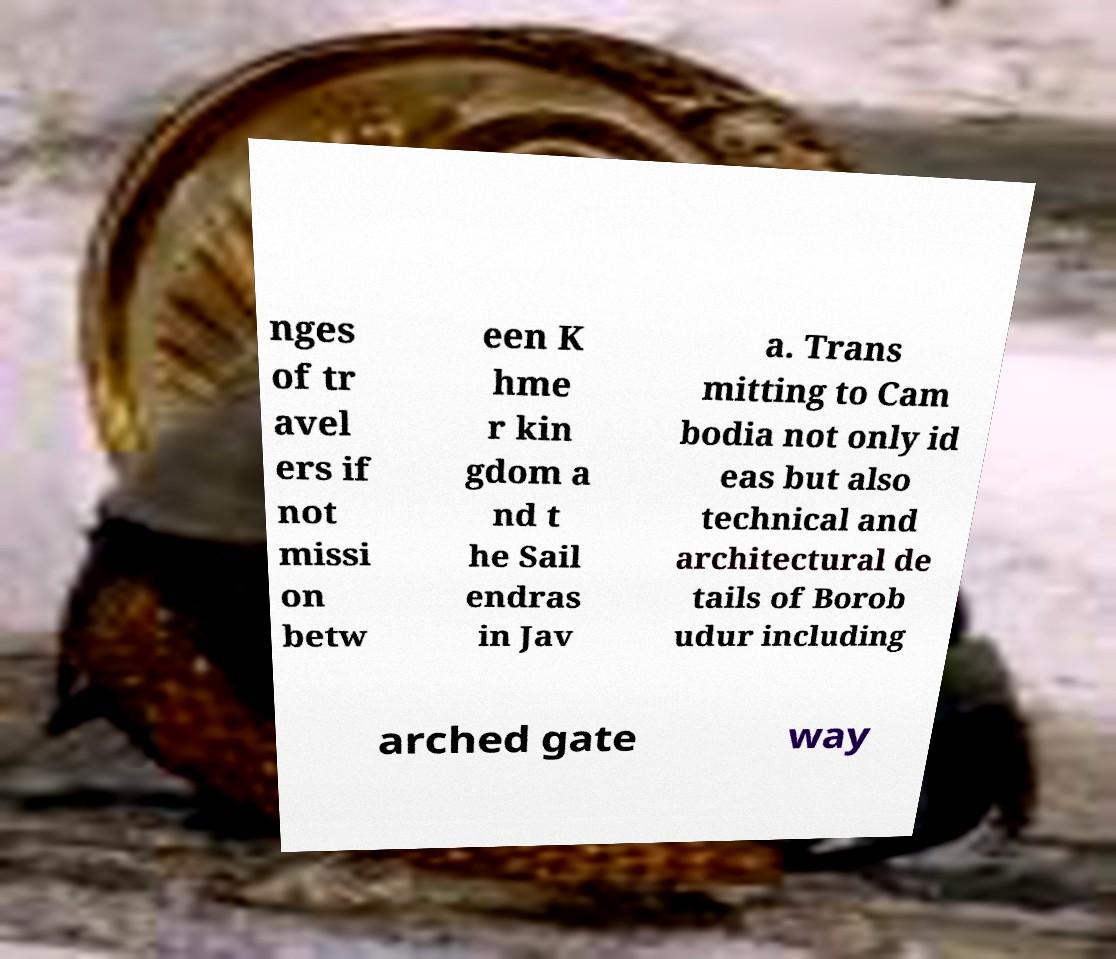There's text embedded in this image that I need extracted. Can you transcribe it verbatim? nges of tr avel ers if not missi on betw een K hme r kin gdom a nd t he Sail endras in Jav a. Trans mitting to Cam bodia not only id eas but also technical and architectural de tails of Borob udur including arched gate way 